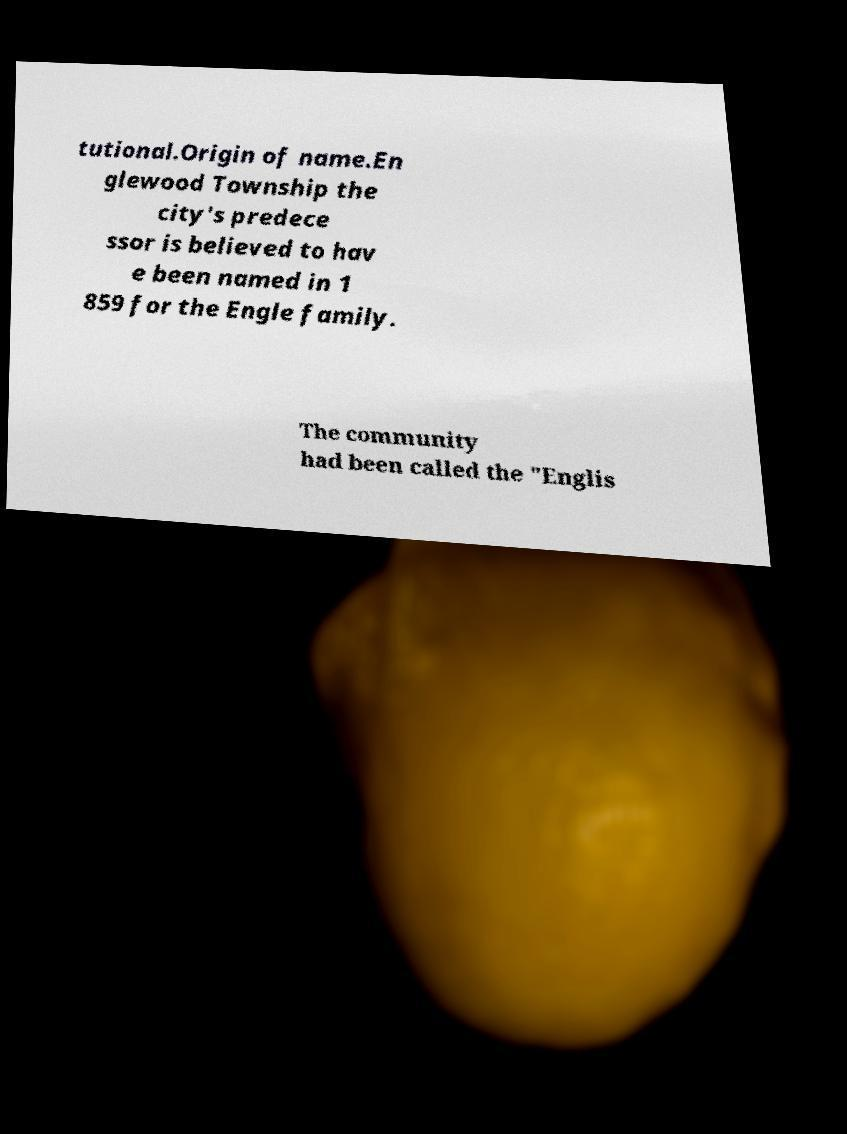There's text embedded in this image that I need extracted. Can you transcribe it verbatim? tutional.Origin of name.En glewood Township the city's predece ssor is believed to hav e been named in 1 859 for the Engle family. The community had been called the "Englis 